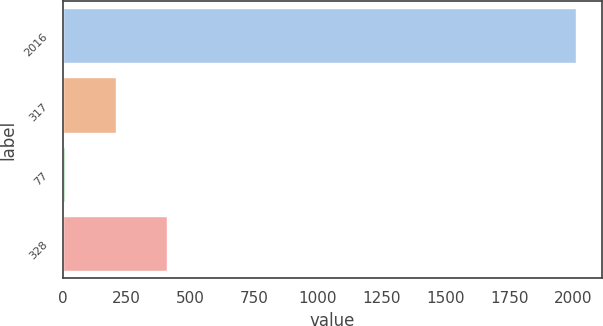Convert chart to OTSL. <chart><loc_0><loc_0><loc_500><loc_500><bar_chart><fcel>2016<fcel>317<fcel>77<fcel>328<nl><fcel>2014<fcel>209.23<fcel>8.7<fcel>409.76<nl></chart> 